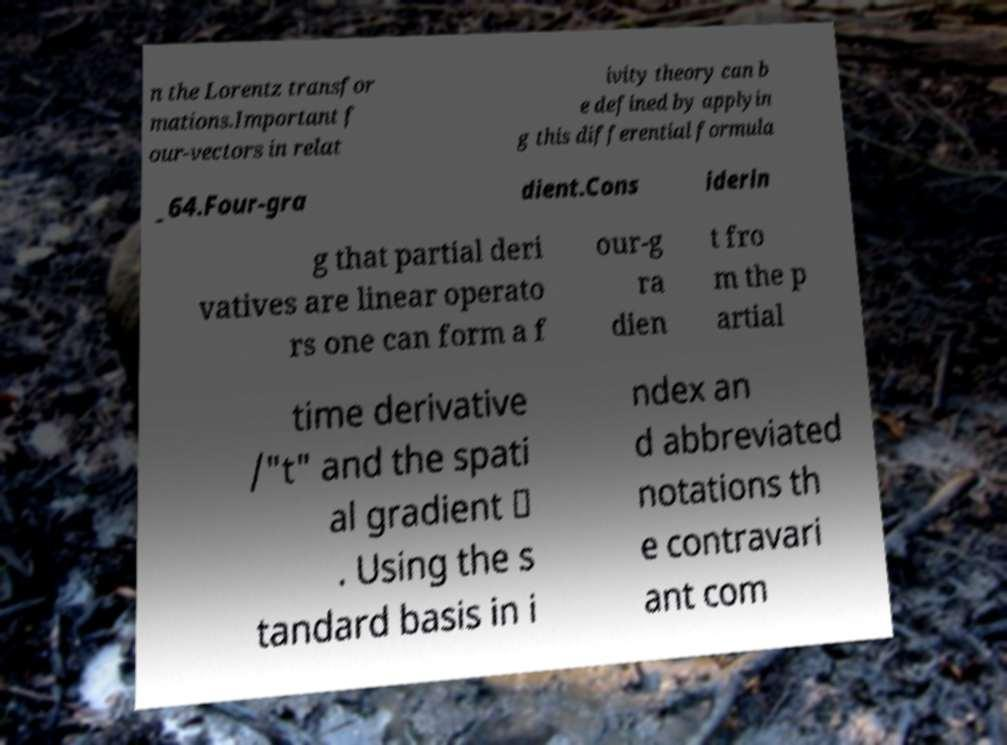Could you extract and type out the text from this image? n the Lorentz transfor mations.Important f our-vectors in relat ivity theory can b e defined by applyin g this differential formula _64.Four-gra dient.Cons iderin g that partial deri vatives are linear operato rs one can form a f our-g ra dien t fro m the p artial time derivative /"t" and the spati al gradient ∇ . Using the s tandard basis in i ndex an d abbreviated notations th e contravari ant com 